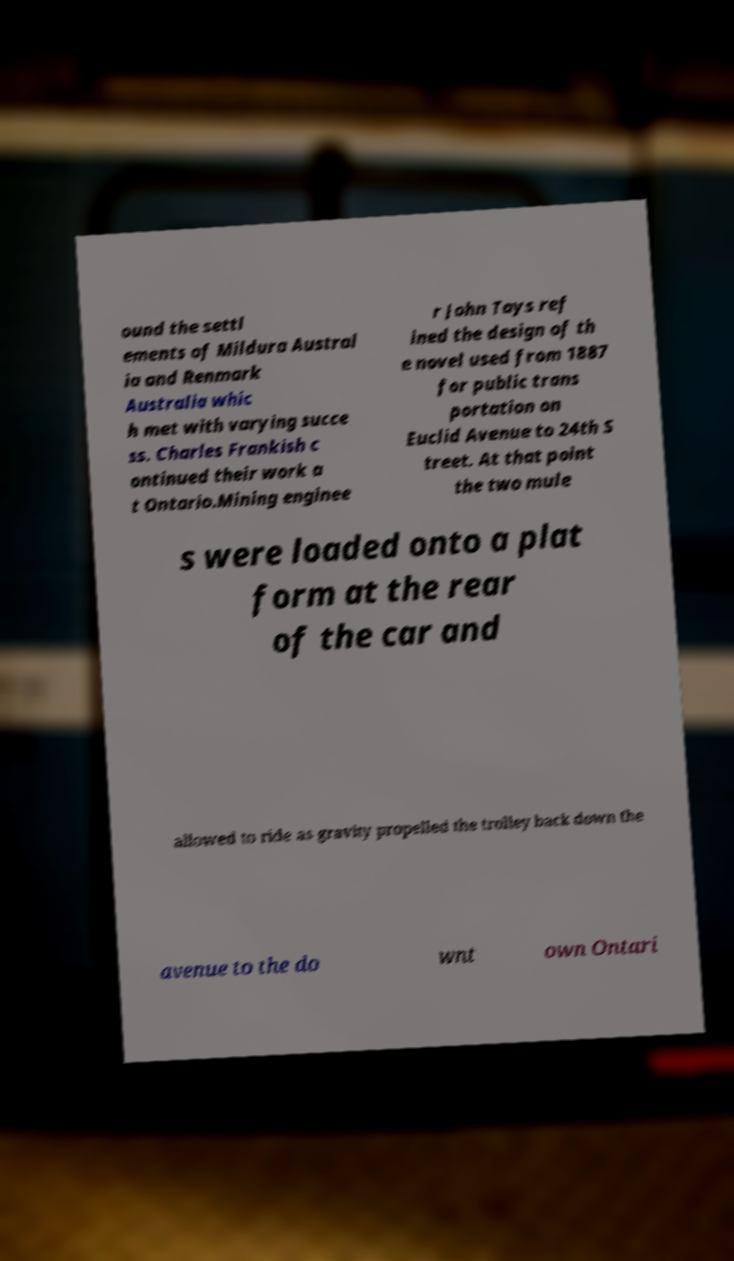Please read and relay the text visible in this image. What does it say? ound the settl ements of Mildura Austral ia and Renmark Australia whic h met with varying succe ss. Charles Frankish c ontinued their work a t Ontario.Mining enginee r John Tays ref ined the design of th e novel used from 1887 for public trans portation on Euclid Avenue to 24th S treet. At that point the two mule s were loaded onto a plat form at the rear of the car and allowed to ride as gravity propelled the trolley back down the avenue to the do wnt own Ontari 